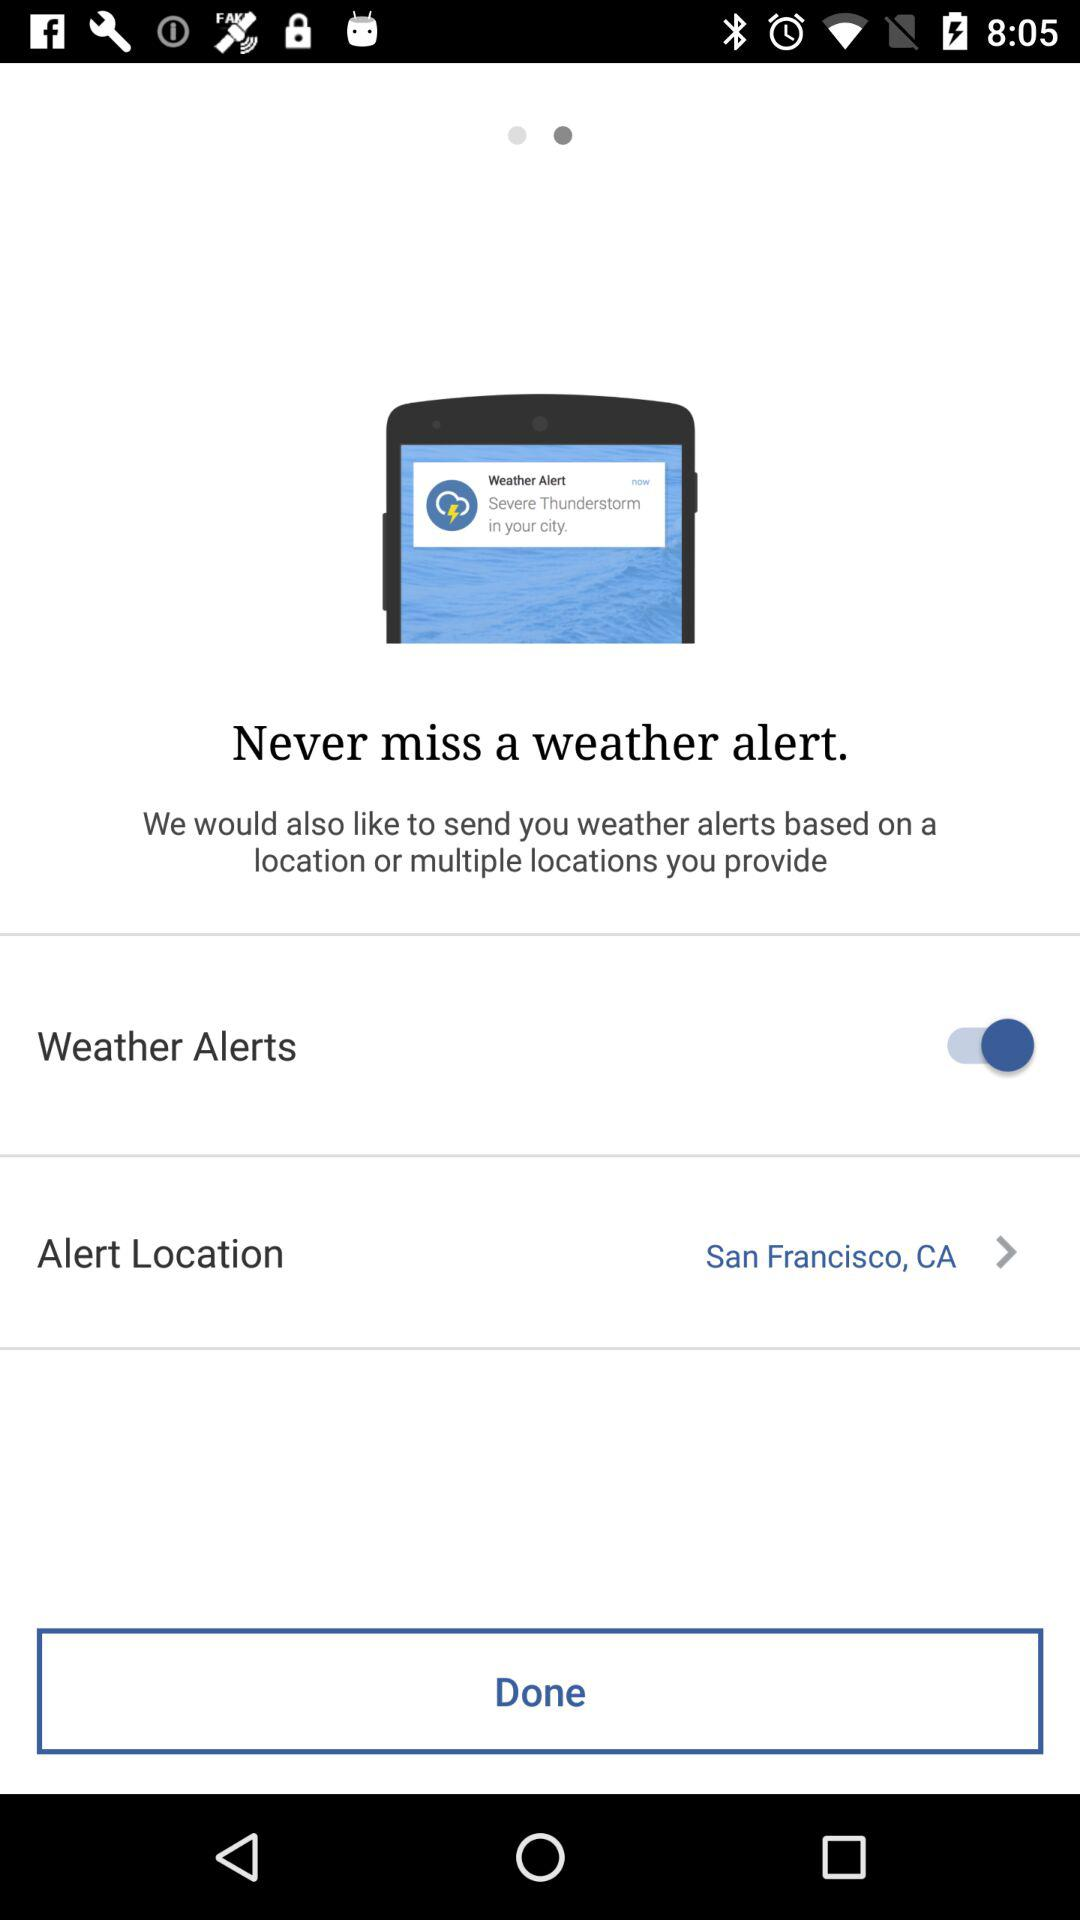What is the alert location? The alert location is San Francisco, CA. 